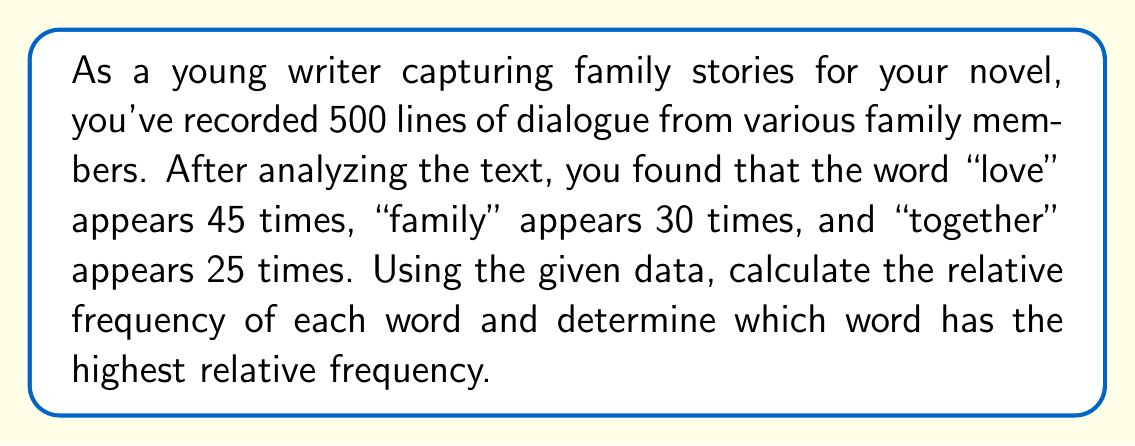Provide a solution to this math problem. To solve this problem, we need to calculate the relative frequency of each word and compare them. The relative frequency is calculated by dividing the number of occurrences of a word by the total number of lines in the dialogue.

Step 1: Calculate the relative frequency for "love"
$$f_{love} = \frac{\text{Number of occurrences}}{\text{Total lines}} = \frac{45}{500} = 0.09$$

Step 2: Calculate the relative frequency for "family"
$$f_{family} = \frac{\text{Number of occurrences}}{\text{Total lines}} = \frac{30}{500} = 0.06$$

Step 3: Calculate the relative frequency for "together"
$$f_{together} = \frac{\text{Number of occurrences}}{\text{Total lines}} = \frac{25}{500} = 0.05$$

Step 4: Compare the relative frequencies
$f_{love} = 0.09$
$f_{family} = 0.06$
$f_{together} = 0.05$

The highest relative frequency is 0.09, which corresponds to the word "love".
Answer: "love" with relative frequency 0.09 